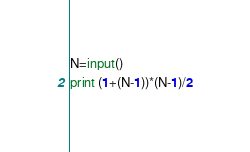Convert code to text. <code><loc_0><loc_0><loc_500><loc_500><_Python_>N=input()
print (1+(N-1))*(N-1)/2</code> 